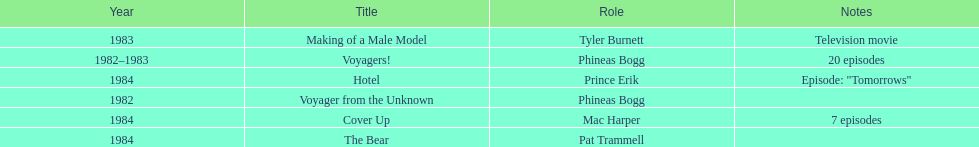Which year did he play the role of mac harper and also pat trammell? 1984. 